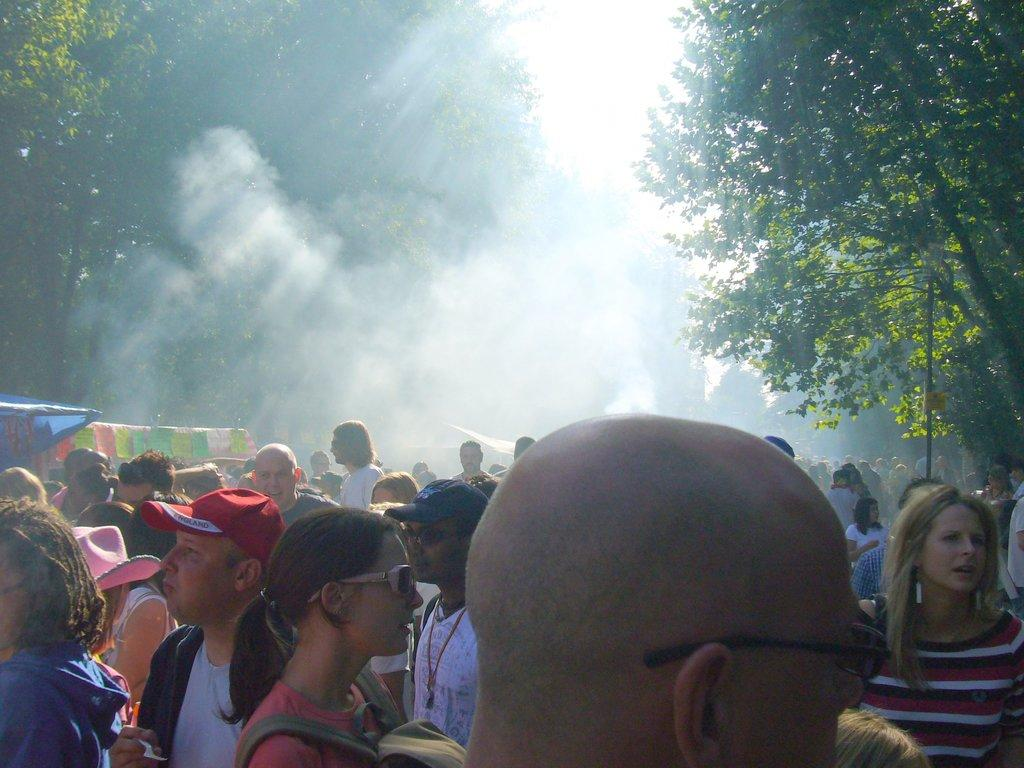What is present in the image involving human subjects? There are people standing in the image. What type of plant can be seen in the image? There is a fig in the image. What type of natural vegetation is visible in the image? There are trees in the image. What part of the natural environment is visible in the image? The sky is visible in the image. What type of duck can be seen walking on the sidewalk in the image? There is no duck or sidewalk present in the image. 